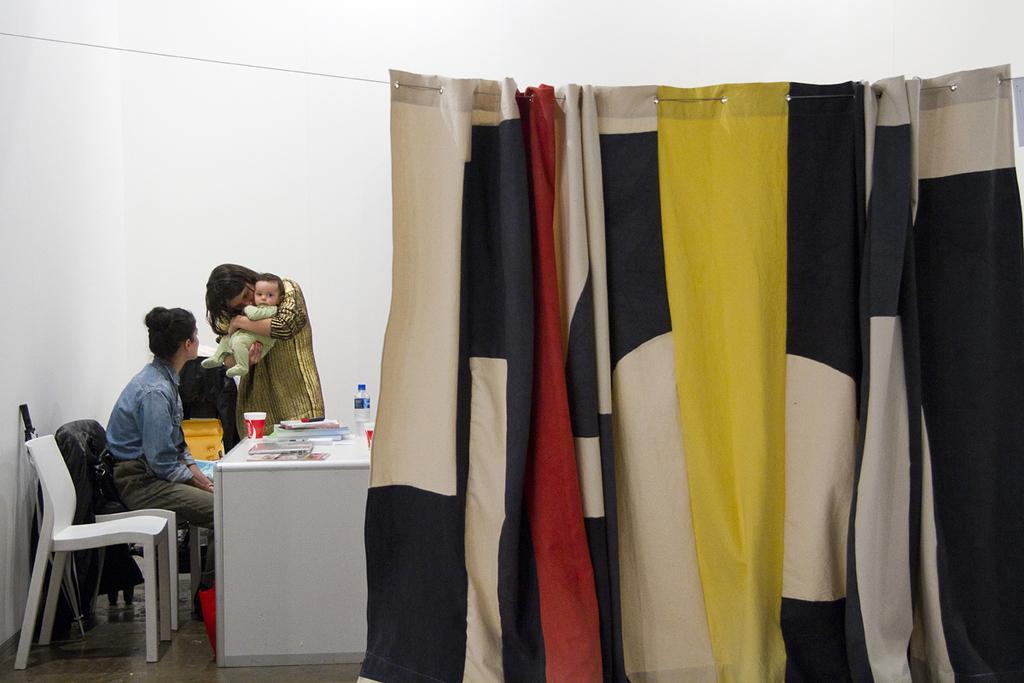Could you give a brief overview of what you see in this image? In this image I can see a curtain with colorful, on the left side I can see two persons a person wearing a yellow color skirt and she holding a baby ,in front of him there is a woman sit on the chair and wearing blue color jacket and background I can see a wall in front of the table there is a book,bottle and glass kept on the table. 